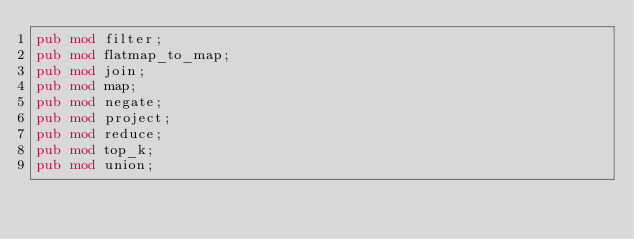Convert code to text. <code><loc_0><loc_0><loc_500><loc_500><_Rust_>pub mod filter;
pub mod flatmap_to_map;
pub mod join;
pub mod map;
pub mod negate;
pub mod project;
pub mod reduce;
pub mod top_k;
pub mod union;
</code> 